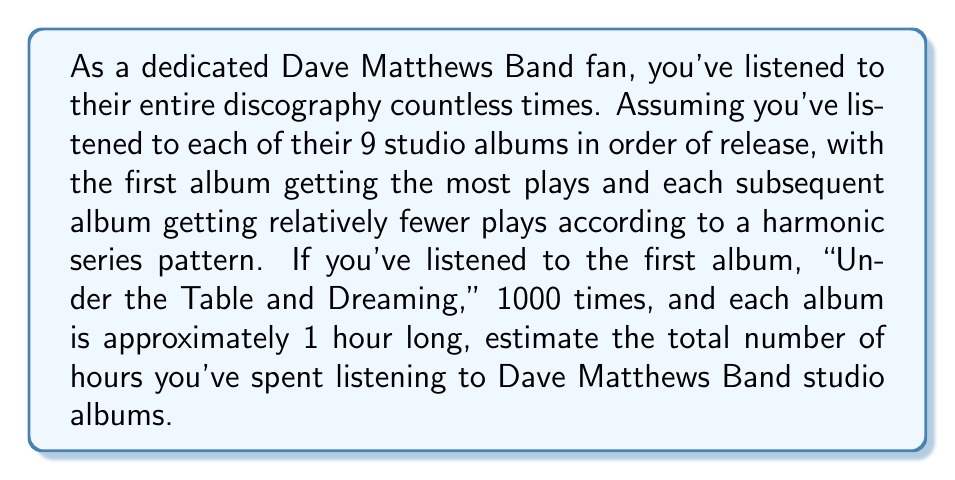Can you answer this question? Let's approach this step-by-step:

1) The harmonic series is defined as: $\sum_{n=1}^{\infty} \frac{1}{n} = 1 + \frac{1}{2} + \frac{1}{3} + \frac{1}{4} + ...$

2) In our case, we have 9 albums, so we'll use the first 9 terms of the harmonic series.

3) Let's calculate the sum of the first 9 terms:

   $$S_9 = 1 + \frac{1}{2} + \frac{1}{3} + \frac{1}{4} + \frac{1}{5} + \frac{1}{6} + \frac{1}{7} + \frac{1}{8} + \frac{1}{9}$$

4) This sum is approximately 2.8289.

5) Now, if the first album was listened to 1000 times, we can calculate the number of listens for each album:

   Album 1: 1000
   Album 2: 1000 * (1/2) = 500
   Album 3: 1000 * (1/3) ≈ 333
   ...
   Album 9: 1000 * (1/9) ≈ 111

6) The total number of listens across all albums is:

   1000 * 2.8289 ≈ 2829 listens

7) If each album is approximately 1 hour long, the total listening time is also 2829 hours.
Answer: The estimated total listening time for Dave Matthews Band studio albums is approximately 2829 hours. 